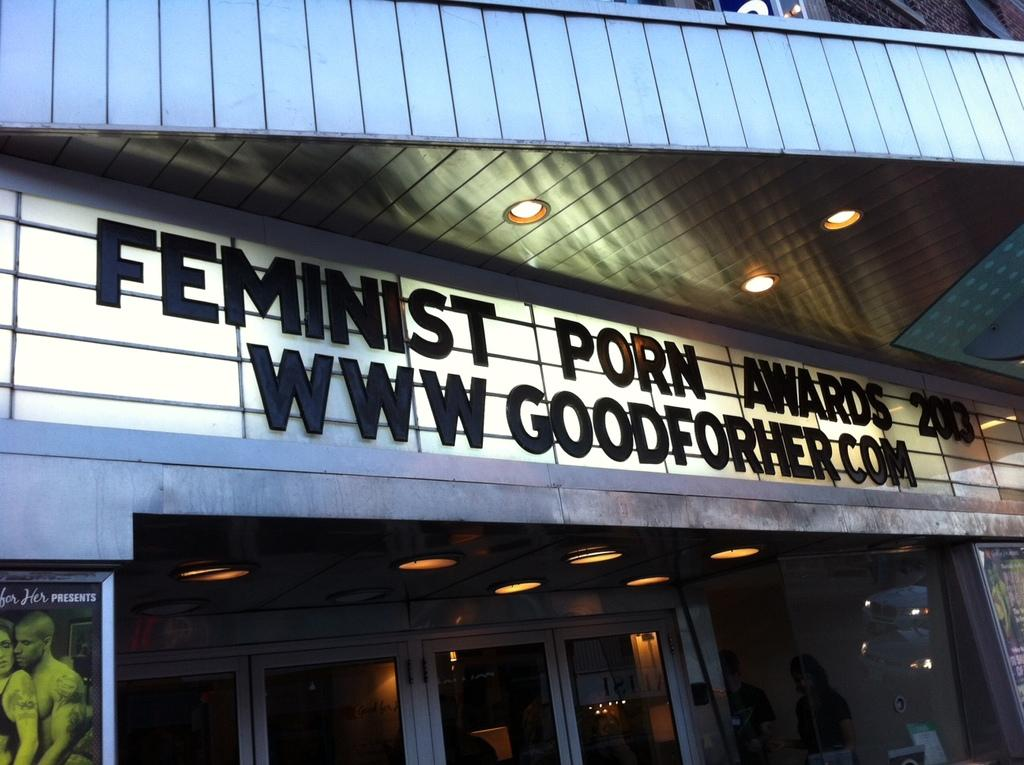What type of structure is visible in the image? There is a building in the image. What can be seen on the building? There is text on the building and lights on the roof. Are there any additional decorations or signs on the building? Yes, there are posters on the wall of the building. Are there any people present in the image? Yes, there are people standing in the image. What type of mitten is being used to hold the corn in the image? There is no mitten or corn present in the image. Is there a sheet covering the building in the image? No, there is no sheet covering the building in the image. 